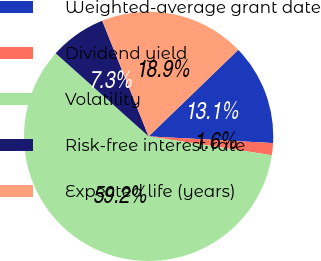<chart> <loc_0><loc_0><loc_500><loc_500><pie_chart><fcel>Weighted-average grant date<fcel>Dividend yield<fcel>Volatility<fcel>Risk-free interest rate<fcel>Expected life (years)<nl><fcel>13.08%<fcel>1.56%<fcel>59.19%<fcel>7.32%<fcel>18.85%<nl></chart> 